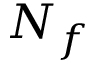Convert formula to latex. <formula><loc_0><loc_0><loc_500><loc_500>N _ { f }</formula> 